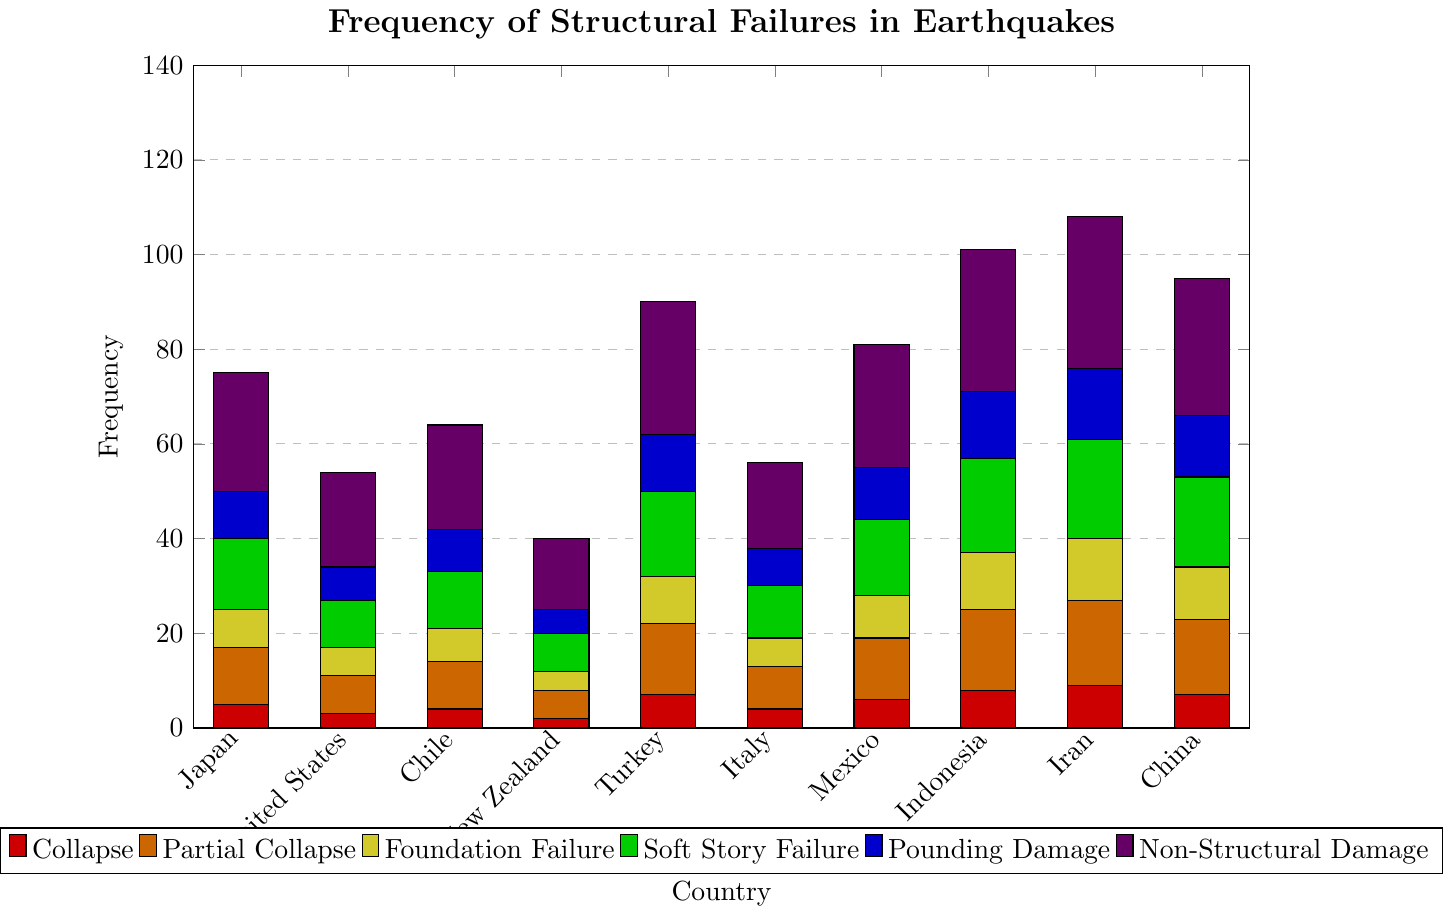Which country has the highest number of non-structural damages? The bar representing non-structural damages is colored in violet. By comparing the height of the bars for each country, the highest is Iran, with a value of 32.
Answer: Iran Which two countries have the lowest frequency of collapses? The bar representing collapses is colored in red. By comparing the height of the bars for each country, the lowest values are for New Zealand (2) and the United States (3).
Answer: New Zealand, United States What is the total frequency of structural failures in Japan? Sum the values of all types of failures in Japan: Collapse (5) + Partial Collapse (12) + Foundation Failure (8) + Soft Story Failure (15) + Pounding Damage (10) + Non-Structural Damage (25) = 75.
Answer: 75 Which type of structural failure is the most common in Turkey? The type can be identified by the color of the bar with the highest value in Turkey. The highest bar for Turkey is Soft Story Failure, colored in green, with a value of 18.
Answer: Soft Story Failure Compare the total frequency of partial collapses in China and New Zealand. Which is higher and by how much? Partial collapses are represented by the orange bars. China has 16 and New Zealand has 6. The difference is 16 - 6 = 10.
Answer: China, 10 What is the average frequency of foundation failures across all countries? Calculate the sum of foundation failures and divide by the number of countries: (8 + 6 + 7 + 4 + 10 + 6 + 9 + 12 + 13 + 11) / 10 = 86 / 10 = 8.6.
Answer: 8.6 Which country has more pounding damage: Indonesia or Mexico? Pounding damage is represented by the blue bars. Indonesia has 14, and Mexico has 11.
Answer: Indonesia What is the frequency difference of non-structural damage between the United States and China? Non-structural damages are represented by the violet bars. The United States has 20, and China has 29. The difference is 29 - 20 = 9.
Answer: 9 How many foundation failures are there in Iran and Turkey combined? Foundation failures are represented by the yellow bars. Iran has 13, and Turkey has 10. The total is 13 + 10 = 23.
Answer: 23 Identify the country with the least soft story failures and provide its frequency. Soft story failures are represented by the green bars. The lowest value is for New Zealand, with a frequency of 8.
Answer: New Zealand, 8 